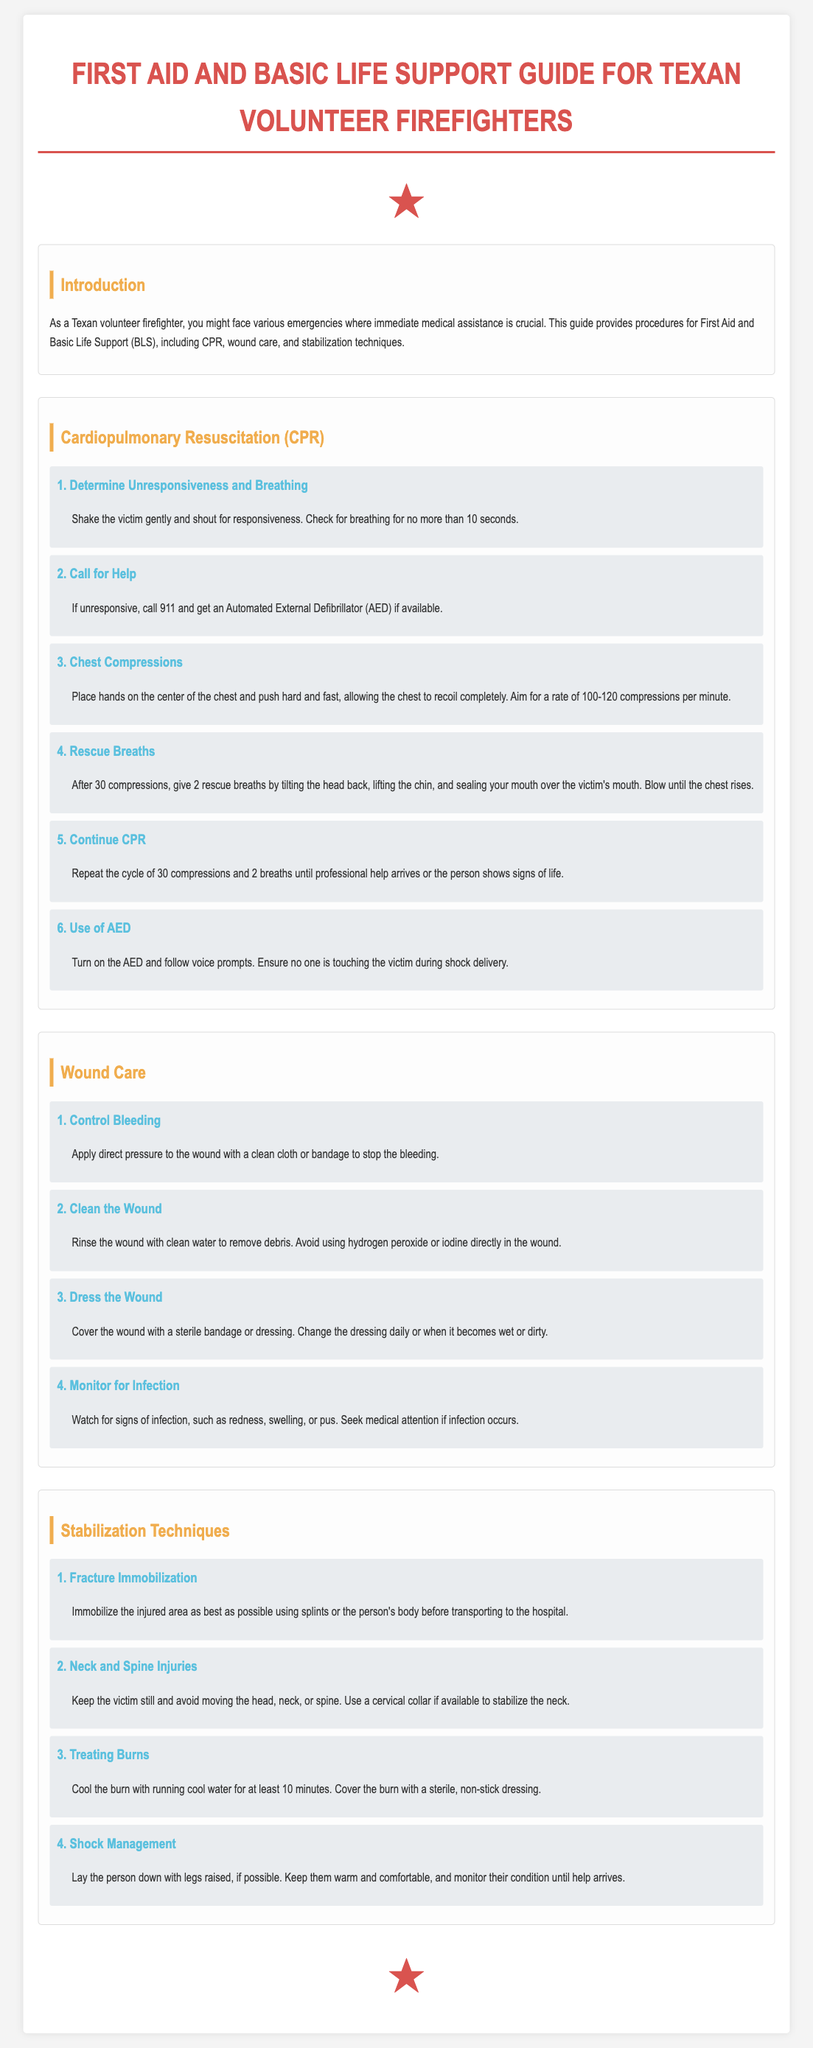what is the title of the document? The title is specified in the header of the document.
Answer: First Aid and Basic Life Support Guide for Texan Volunteer Firefighters how many steps are there for CPR? The CPR section lists the number of steps provided.
Answer: 6 what should you do if the victim is unresponsive? This is addressed in step 2 of the CPR section.
Answer: Call 911 and get an AED which technique is used for shock management? The stabilization technique for shock management is outlined.
Answer: Lay the person down with legs raised how long should you cool a burn? The instruction for treating burns specifies the cooling duration.
Answer: 10 minutes what is the purpose of a cervical collar? The document specifies the role of the cervical collar.
Answer: To stabilize the neck what should you monitor for after dressing a wound? This is included in the wound care section as a follow-up measure.
Answer: Signs of infection what is the recommended compression rate for CPR? This information is found under the chest compressions step.
Answer: 100-120 compressions per minute 